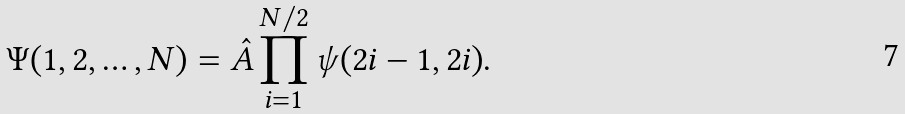<formula> <loc_0><loc_0><loc_500><loc_500>\Psi ( 1 , 2 , \dots , N ) = \hat { A } \prod _ { i = 1 } ^ { N / 2 } \psi ( 2 i - 1 , 2 i ) .</formula> 